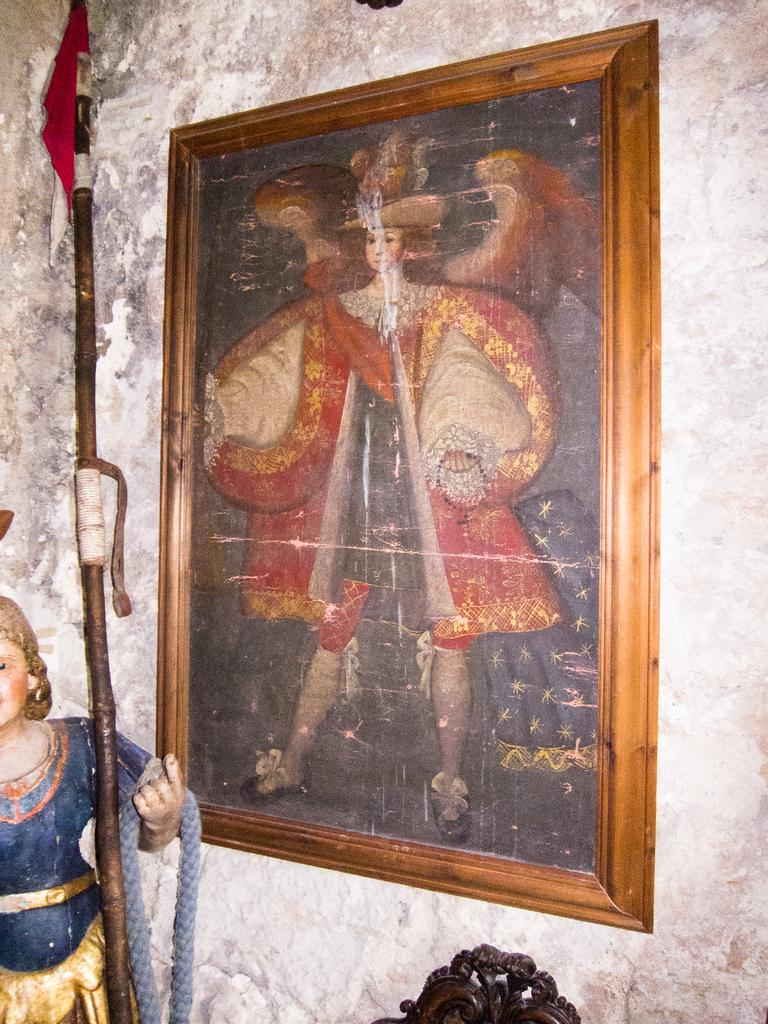What is the main subject of the image? There is a sculpture of a person in the image. What else can be seen in the image besides the sculpture? There is a flag with a pole and a frame attached to the wall in the image. How many brothers are standing next to the sculpture in the image? There are no brothers present in the image; it only features a sculpture of a person, a flag with a pole, and a frame attached to the wall. 